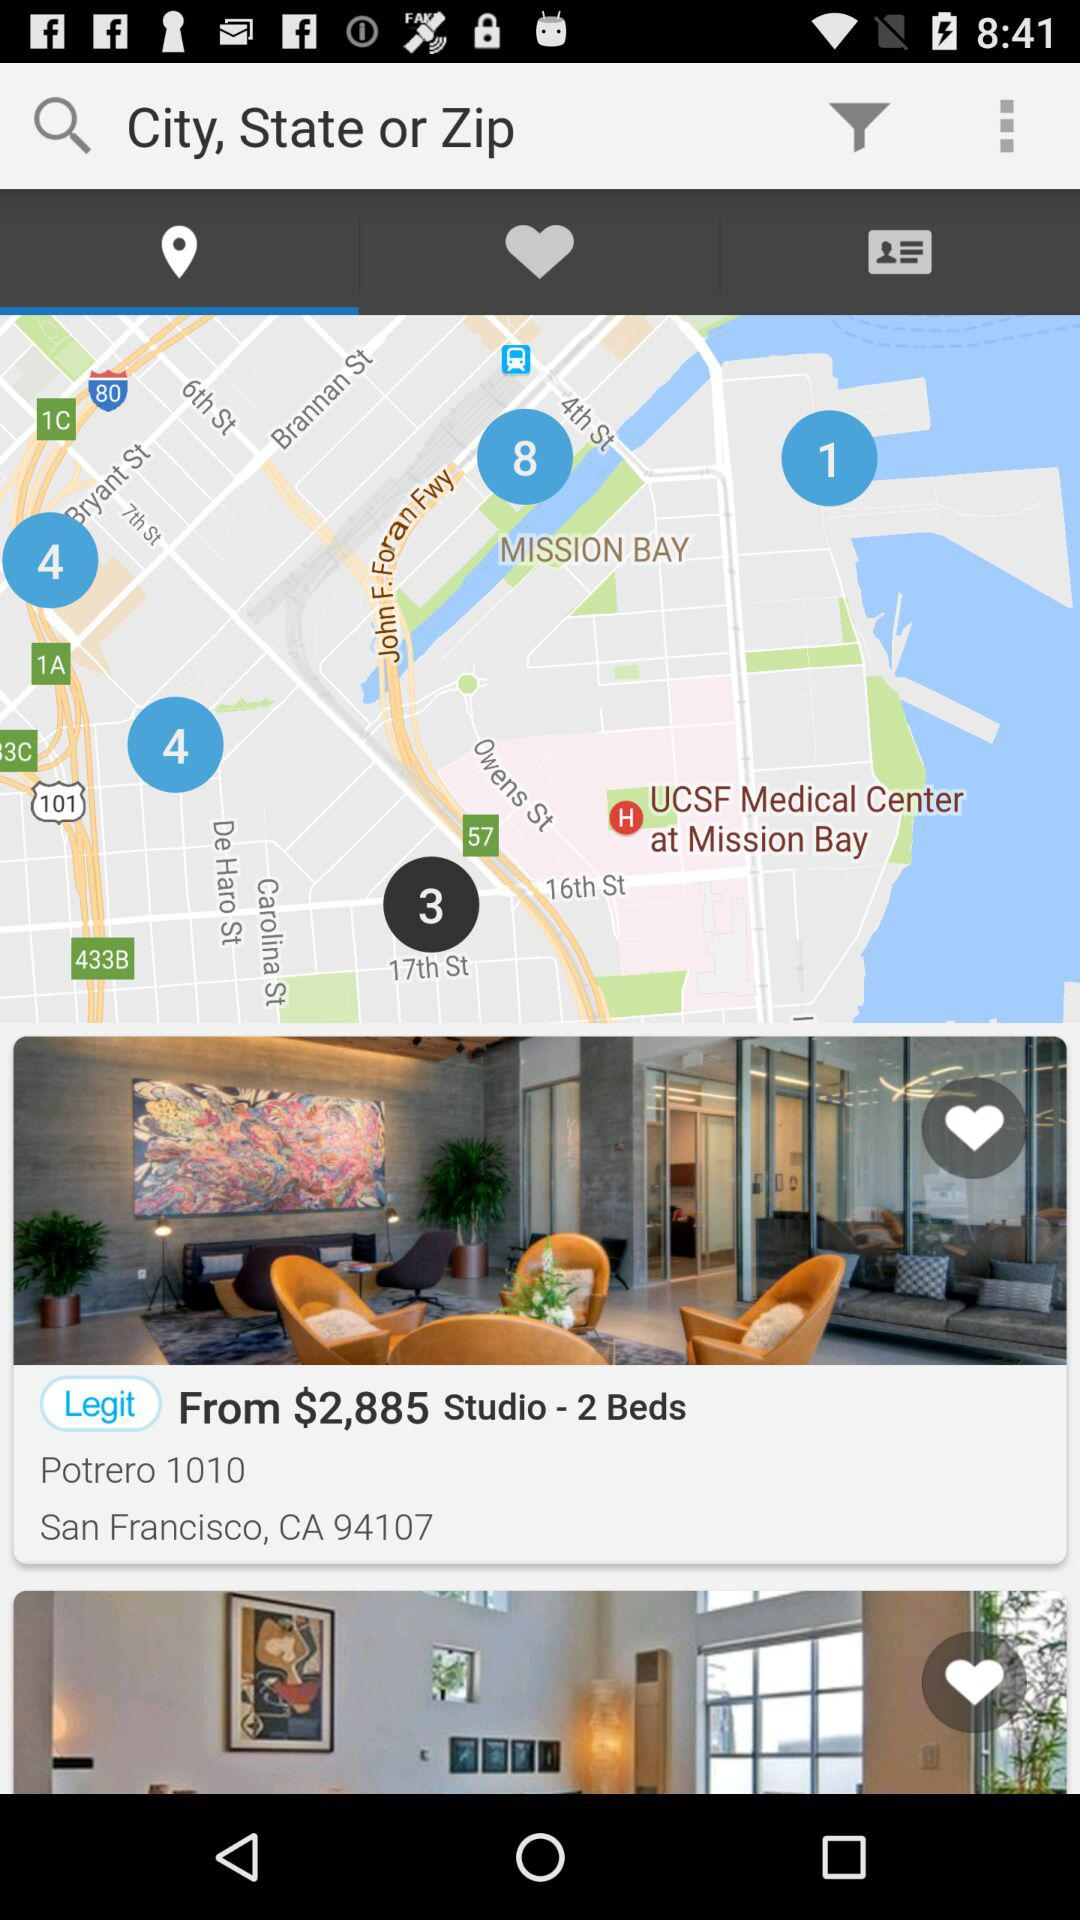What is the price of the studio? The price of the studio starts at $2,885. 